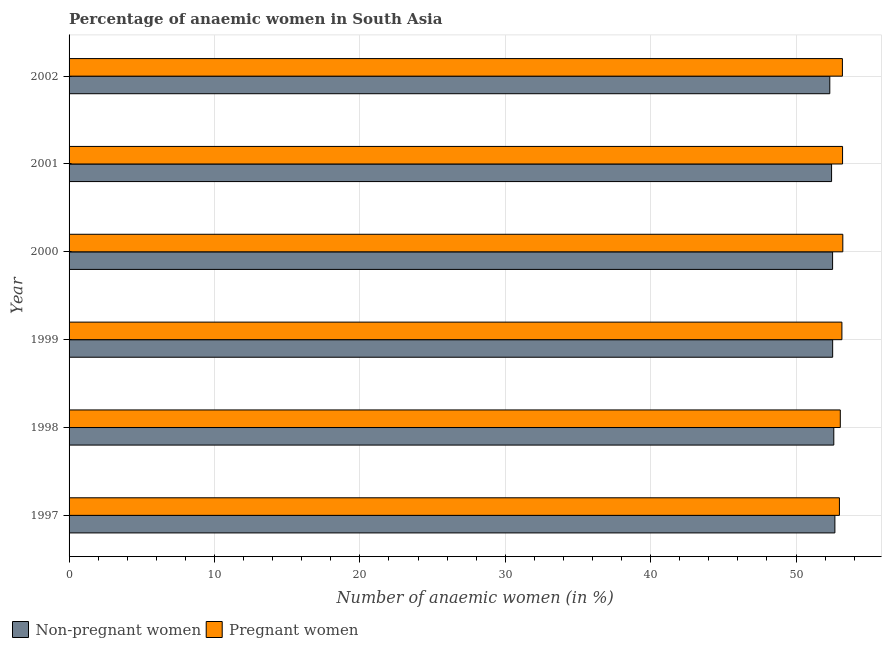How many groups of bars are there?
Ensure brevity in your answer.  6. Are the number of bars per tick equal to the number of legend labels?
Your answer should be very brief. Yes. In how many cases, is the number of bars for a given year not equal to the number of legend labels?
Provide a short and direct response. 0. What is the percentage of non-pregnant anaemic women in 2000?
Provide a succinct answer. 52.52. Across all years, what is the maximum percentage of pregnant anaemic women?
Your answer should be very brief. 53.22. Across all years, what is the minimum percentage of non-pregnant anaemic women?
Offer a very short reply. 52.32. In which year was the percentage of non-pregnant anaemic women maximum?
Provide a short and direct response. 1997. In which year was the percentage of non-pregnant anaemic women minimum?
Offer a very short reply. 2002. What is the total percentage of non-pregnant anaemic women in the graph?
Give a very brief answer. 315.08. What is the difference between the percentage of non-pregnant anaemic women in 1998 and that in 2000?
Ensure brevity in your answer.  0.08. What is the difference between the percentage of pregnant anaemic women in 1998 and the percentage of non-pregnant anaemic women in 2002?
Provide a short and direct response. 0.72. What is the average percentage of pregnant anaemic women per year?
Keep it short and to the point. 53.13. In the year 1997, what is the difference between the percentage of pregnant anaemic women and percentage of non-pregnant anaemic women?
Your answer should be very brief. 0.31. What is the difference between the highest and the second highest percentage of non-pregnant anaemic women?
Your response must be concise. 0.07. What is the difference between the highest and the lowest percentage of pregnant anaemic women?
Keep it short and to the point. 0.23. Is the sum of the percentage of non-pregnant anaemic women in 1998 and 2002 greater than the maximum percentage of pregnant anaemic women across all years?
Provide a succinct answer. Yes. What does the 2nd bar from the top in 2000 represents?
Provide a succinct answer. Non-pregnant women. What does the 1st bar from the bottom in 2001 represents?
Your answer should be very brief. Non-pregnant women. How many bars are there?
Give a very brief answer. 12. Does the graph contain grids?
Your answer should be very brief. Yes. How many legend labels are there?
Give a very brief answer. 2. How are the legend labels stacked?
Give a very brief answer. Horizontal. What is the title of the graph?
Keep it short and to the point. Percentage of anaemic women in South Asia. What is the label or title of the X-axis?
Your answer should be compact. Number of anaemic women (in %). What is the Number of anaemic women (in %) in Non-pregnant women in 1997?
Provide a succinct answer. 52.67. What is the Number of anaemic women (in %) of Pregnant women in 1997?
Provide a succinct answer. 52.99. What is the Number of anaemic women (in %) in Non-pregnant women in 1998?
Your answer should be very brief. 52.6. What is the Number of anaemic women (in %) in Pregnant women in 1998?
Offer a terse response. 53.05. What is the Number of anaemic women (in %) of Non-pregnant women in 1999?
Provide a succinct answer. 52.52. What is the Number of anaemic women (in %) in Pregnant women in 1999?
Your answer should be compact. 53.16. What is the Number of anaemic women (in %) in Non-pregnant women in 2000?
Make the answer very short. 52.52. What is the Number of anaemic women (in %) in Pregnant women in 2000?
Ensure brevity in your answer.  53.22. What is the Number of anaemic women (in %) of Non-pregnant women in 2001?
Ensure brevity in your answer.  52.45. What is the Number of anaemic women (in %) of Pregnant women in 2001?
Your response must be concise. 53.2. What is the Number of anaemic women (in %) of Non-pregnant women in 2002?
Give a very brief answer. 52.32. What is the Number of anaemic women (in %) in Pregnant women in 2002?
Offer a very short reply. 53.19. Across all years, what is the maximum Number of anaemic women (in %) in Non-pregnant women?
Ensure brevity in your answer.  52.67. Across all years, what is the maximum Number of anaemic women (in %) of Pregnant women?
Offer a very short reply. 53.22. Across all years, what is the minimum Number of anaemic women (in %) of Non-pregnant women?
Provide a short and direct response. 52.32. Across all years, what is the minimum Number of anaemic women (in %) of Pregnant women?
Your answer should be compact. 52.99. What is the total Number of anaemic women (in %) of Non-pregnant women in the graph?
Make the answer very short. 315.08. What is the total Number of anaemic women (in %) in Pregnant women in the graph?
Give a very brief answer. 318.8. What is the difference between the Number of anaemic women (in %) of Non-pregnant women in 1997 and that in 1998?
Your answer should be very brief. 0.07. What is the difference between the Number of anaemic women (in %) in Pregnant women in 1997 and that in 1998?
Provide a succinct answer. -0.06. What is the difference between the Number of anaemic women (in %) in Non-pregnant women in 1997 and that in 1999?
Offer a very short reply. 0.15. What is the difference between the Number of anaemic women (in %) in Pregnant women in 1997 and that in 1999?
Provide a short and direct response. -0.17. What is the difference between the Number of anaemic women (in %) in Non-pregnant women in 1997 and that in 2000?
Offer a very short reply. 0.16. What is the difference between the Number of anaemic women (in %) of Pregnant women in 1997 and that in 2000?
Keep it short and to the point. -0.23. What is the difference between the Number of anaemic women (in %) of Non-pregnant women in 1997 and that in 2001?
Give a very brief answer. 0.23. What is the difference between the Number of anaemic women (in %) in Pregnant women in 1997 and that in 2001?
Ensure brevity in your answer.  -0.22. What is the difference between the Number of anaemic women (in %) in Non-pregnant women in 1997 and that in 2002?
Provide a short and direct response. 0.35. What is the difference between the Number of anaemic women (in %) in Pregnant women in 1997 and that in 2002?
Ensure brevity in your answer.  -0.21. What is the difference between the Number of anaemic women (in %) in Non-pregnant women in 1998 and that in 1999?
Make the answer very short. 0.08. What is the difference between the Number of anaemic women (in %) of Pregnant women in 1998 and that in 1999?
Offer a very short reply. -0.11. What is the difference between the Number of anaemic women (in %) of Non-pregnant women in 1998 and that in 2000?
Provide a succinct answer. 0.08. What is the difference between the Number of anaemic women (in %) in Pregnant women in 1998 and that in 2000?
Make the answer very short. -0.17. What is the difference between the Number of anaemic women (in %) of Non-pregnant women in 1998 and that in 2001?
Your response must be concise. 0.15. What is the difference between the Number of anaemic women (in %) of Pregnant women in 1998 and that in 2001?
Provide a short and direct response. -0.16. What is the difference between the Number of anaemic women (in %) of Non-pregnant women in 1998 and that in 2002?
Provide a short and direct response. 0.28. What is the difference between the Number of anaemic women (in %) of Pregnant women in 1998 and that in 2002?
Give a very brief answer. -0.14. What is the difference between the Number of anaemic women (in %) in Non-pregnant women in 1999 and that in 2000?
Your response must be concise. 0. What is the difference between the Number of anaemic women (in %) of Pregnant women in 1999 and that in 2000?
Provide a succinct answer. -0.06. What is the difference between the Number of anaemic women (in %) of Non-pregnant women in 1999 and that in 2001?
Your response must be concise. 0.07. What is the difference between the Number of anaemic women (in %) of Pregnant women in 1999 and that in 2001?
Make the answer very short. -0.04. What is the difference between the Number of anaemic women (in %) in Non-pregnant women in 1999 and that in 2002?
Provide a short and direct response. 0.2. What is the difference between the Number of anaemic women (in %) of Pregnant women in 1999 and that in 2002?
Make the answer very short. -0.03. What is the difference between the Number of anaemic women (in %) in Non-pregnant women in 2000 and that in 2001?
Your answer should be compact. 0.07. What is the difference between the Number of anaemic women (in %) of Pregnant women in 2000 and that in 2001?
Keep it short and to the point. 0.02. What is the difference between the Number of anaemic women (in %) of Non-pregnant women in 2000 and that in 2002?
Provide a short and direct response. 0.19. What is the difference between the Number of anaemic women (in %) in Pregnant women in 2000 and that in 2002?
Make the answer very short. 0.03. What is the difference between the Number of anaemic women (in %) of Non-pregnant women in 2001 and that in 2002?
Your answer should be compact. 0.12. What is the difference between the Number of anaemic women (in %) in Pregnant women in 2001 and that in 2002?
Offer a terse response. 0.01. What is the difference between the Number of anaemic women (in %) in Non-pregnant women in 1997 and the Number of anaemic women (in %) in Pregnant women in 1998?
Offer a very short reply. -0.37. What is the difference between the Number of anaemic women (in %) of Non-pregnant women in 1997 and the Number of anaemic women (in %) of Pregnant women in 1999?
Your answer should be compact. -0.48. What is the difference between the Number of anaemic women (in %) of Non-pregnant women in 1997 and the Number of anaemic women (in %) of Pregnant women in 2000?
Your answer should be very brief. -0.54. What is the difference between the Number of anaemic women (in %) in Non-pregnant women in 1997 and the Number of anaemic women (in %) in Pregnant women in 2001?
Keep it short and to the point. -0.53. What is the difference between the Number of anaemic women (in %) in Non-pregnant women in 1997 and the Number of anaemic women (in %) in Pregnant women in 2002?
Provide a short and direct response. -0.52. What is the difference between the Number of anaemic women (in %) of Non-pregnant women in 1998 and the Number of anaemic women (in %) of Pregnant women in 1999?
Provide a short and direct response. -0.56. What is the difference between the Number of anaemic women (in %) in Non-pregnant women in 1998 and the Number of anaemic women (in %) in Pregnant women in 2000?
Offer a terse response. -0.62. What is the difference between the Number of anaemic women (in %) of Non-pregnant women in 1998 and the Number of anaemic women (in %) of Pregnant women in 2001?
Ensure brevity in your answer.  -0.6. What is the difference between the Number of anaemic women (in %) in Non-pregnant women in 1998 and the Number of anaemic women (in %) in Pregnant women in 2002?
Offer a terse response. -0.59. What is the difference between the Number of anaemic women (in %) in Non-pregnant women in 1999 and the Number of anaemic women (in %) in Pregnant women in 2000?
Provide a succinct answer. -0.7. What is the difference between the Number of anaemic women (in %) of Non-pregnant women in 1999 and the Number of anaemic women (in %) of Pregnant women in 2001?
Your answer should be very brief. -0.68. What is the difference between the Number of anaemic women (in %) in Non-pregnant women in 1999 and the Number of anaemic women (in %) in Pregnant women in 2002?
Your answer should be compact. -0.67. What is the difference between the Number of anaemic women (in %) of Non-pregnant women in 2000 and the Number of anaemic women (in %) of Pregnant women in 2001?
Offer a very short reply. -0.69. What is the difference between the Number of anaemic women (in %) of Non-pregnant women in 2000 and the Number of anaemic women (in %) of Pregnant women in 2002?
Keep it short and to the point. -0.68. What is the difference between the Number of anaemic women (in %) in Non-pregnant women in 2001 and the Number of anaemic women (in %) in Pregnant women in 2002?
Give a very brief answer. -0.75. What is the average Number of anaemic women (in %) in Non-pregnant women per year?
Offer a terse response. 52.51. What is the average Number of anaemic women (in %) in Pregnant women per year?
Provide a short and direct response. 53.13. In the year 1997, what is the difference between the Number of anaemic women (in %) of Non-pregnant women and Number of anaemic women (in %) of Pregnant women?
Your answer should be very brief. -0.31. In the year 1998, what is the difference between the Number of anaemic women (in %) of Non-pregnant women and Number of anaemic women (in %) of Pregnant women?
Provide a short and direct response. -0.45. In the year 1999, what is the difference between the Number of anaemic women (in %) of Non-pregnant women and Number of anaemic women (in %) of Pregnant women?
Provide a succinct answer. -0.64. In the year 2000, what is the difference between the Number of anaemic women (in %) of Non-pregnant women and Number of anaemic women (in %) of Pregnant women?
Give a very brief answer. -0.7. In the year 2001, what is the difference between the Number of anaemic women (in %) in Non-pregnant women and Number of anaemic women (in %) in Pregnant women?
Provide a short and direct response. -0.76. In the year 2002, what is the difference between the Number of anaemic women (in %) of Non-pregnant women and Number of anaemic women (in %) of Pregnant women?
Your answer should be compact. -0.87. What is the ratio of the Number of anaemic women (in %) of Non-pregnant women in 1997 to that in 1999?
Your answer should be compact. 1. What is the ratio of the Number of anaemic women (in %) of Non-pregnant women in 1997 to that in 2000?
Your answer should be compact. 1. What is the ratio of the Number of anaemic women (in %) in Pregnant women in 1997 to that in 2000?
Your answer should be compact. 1. What is the ratio of the Number of anaemic women (in %) of Pregnant women in 1997 to that in 2001?
Your response must be concise. 1. What is the ratio of the Number of anaemic women (in %) in Non-pregnant women in 1997 to that in 2002?
Provide a short and direct response. 1.01. What is the ratio of the Number of anaemic women (in %) in Pregnant women in 1997 to that in 2002?
Offer a very short reply. 1. What is the ratio of the Number of anaemic women (in %) in Pregnant women in 1998 to that in 1999?
Make the answer very short. 1. What is the ratio of the Number of anaemic women (in %) in Non-pregnant women in 1998 to that in 2000?
Your answer should be very brief. 1. What is the ratio of the Number of anaemic women (in %) of Pregnant women in 1998 to that in 2000?
Your response must be concise. 1. What is the ratio of the Number of anaemic women (in %) of Non-pregnant women in 1998 to that in 2001?
Your answer should be very brief. 1. What is the ratio of the Number of anaemic women (in %) in Pregnant women in 1998 to that in 2001?
Ensure brevity in your answer.  1. What is the ratio of the Number of anaemic women (in %) of Pregnant women in 1998 to that in 2002?
Offer a terse response. 1. What is the ratio of the Number of anaemic women (in %) in Non-pregnant women in 1999 to that in 2000?
Your answer should be very brief. 1. What is the ratio of the Number of anaemic women (in %) in Non-pregnant women in 1999 to that in 2001?
Make the answer very short. 1. What is the ratio of the Number of anaemic women (in %) in Pregnant women in 1999 to that in 2002?
Your answer should be compact. 1. What is the ratio of the Number of anaemic women (in %) in Non-pregnant women in 2000 to that in 2001?
Provide a succinct answer. 1. What is the ratio of the Number of anaemic women (in %) of Pregnant women in 2000 to that in 2001?
Provide a succinct answer. 1. What is the ratio of the Number of anaemic women (in %) of Non-pregnant women in 2000 to that in 2002?
Give a very brief answer. 1. What is the ratio of the Number of anaemic women (in %) of Non-pregnant women in 2001 to that in 2002?
Your answer should be very brief. 1. What is the ratio of the Number of anaemic women (in %) in Pregnant women in 2001 to that in 2002?
Your answer should be compact. 1. What is the difference between the highest and the second highest Number of anaemic women (in %) in Non-pregnant women?
Offer a terse response. 0.07. What is the difference between the highest and the second highest Number of anaemic women (in %) in Pregnant women?
Make the answer very short. 0.02. What is the difference between the highest and the lowest Number of anaemic women (in %) of Non-pregnant women?
Ensure brevity in your answer.  0.35. What is the difference between the highest and the lowest Number of anaemic women (in %) in Pregnant women?
Keep it short and to the point. 0.23. 